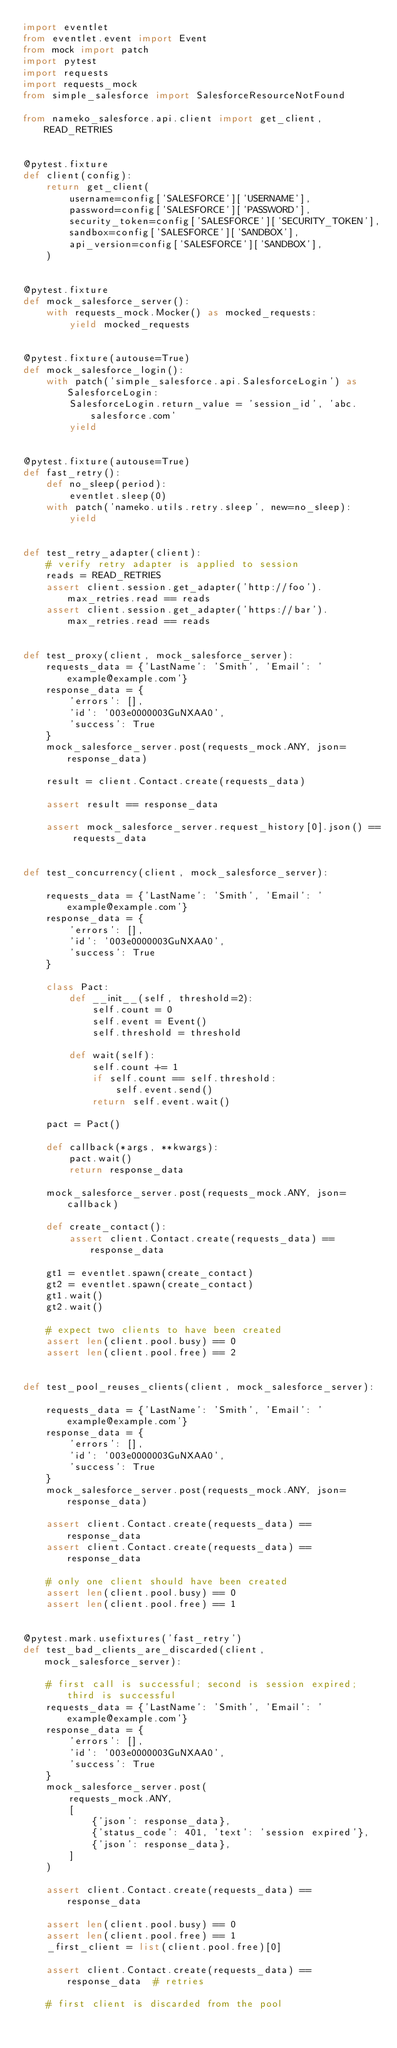<code> <loc_0><loc_0><loc_500><loc_500><_Python_>import eventlet
from eventlet.event import Event
from mock import patch
import pytest
import requests
import requests_mock
from simple_salesforce import SalesforceResourceNotFound

from nameko_salesforce.api.client import get_client, READ_RETRIES


@pytest.fixture
def client(config):
    return get_client(
        username=config['SALESFORCE']['USERNAME'],
        password=config['SALESFORCE']['PASSWORD'],
        security_token=config['SALESFORCE']['SECURITY_TOKEN'],
        sandbox=config['SALESFORCE']['SANDBOX'],
        api_version=config['SALESFORCE']['SANDBOX'],
    )


@pytest.fixture
def mock_salesforce_server():
    with requests_mock.Mocker() as mocked_requests:
        yield mocked_requests


@pytest.fixture(autouse=True)
def mock_salesforce_login():
    with patch('simple_salesforce.api.SalesforceLogin') as SalesforceLogin:
        SalesforceLogin.return_value = 'session_id', 'abc.salesforce.com'
        yield


@pytest.fixture(autouse=True)
def fast_retry():
    def no_sleep(period):
        eventlet.sleep(0)
    with patch('nameko.utils.retry.sleep', new=no_sleep):
        yield


def test_retry_adapter(client):
    # verify retry adapter is applied to session
    reads = READ_RETRIES
    assert client.session.get_adapter('http://foo').max_retries.read == reads
    assert client.session.get_adapter('https://bar').max_retries.read == reads


def test_proxy(client, mock_salesforce_server):
    requests_data = {'LastName': 'Smith', 'Email': 'example@example.com'}
    response_data = {
        'errors': [],
        'id': '003e0000003GuNXAA0',
        'success': True
    }
    mock_salesforce_server.post(requests_mock.ANY, json=response_data)

    result = client.Contact.create(requests_data)

    assert result == response_data

    assert mock_salesforce_server.request_history[0].json() == requests_data


def test_concurrency(client, mock_salesforce_server):

    requests_data = {'LastName': 'Smith', 'Email': 'example@example.com'}
    response_data = {
        'errors': [],
        'id': '003e0000003GuNXAA0',
        'success': True
    }

    class Pact:
        def __init__(self, threshold=2):
            self.count = 0
            self.event = Event()
            self.threshold = threshold

        def wait(self):
            self.count += 1
            if self.count == self.threshold:
                self.event.send()
            return self.event.wait()

    pact = Pact()

    def callback(*args, **kwargs):
        pact.wait()
        return response_data

    mock_salesforce_server.post(requests_mock.ANY, json=callback)

    def create_contact():
        assert client.Contact.create(requests_data) == response_data

    gt1 = eventlet.spawn(create_contact)
    gt2 = eventlet.spawn(create_contact)
    gt1.wait()
    gt2.wait()

    # expect two clients to have been created
    assert len(client.pool.busy) == 0
    assert len(client.pool.free) == 2


def test_pool_reuses_clients(client, mock_salesforce_server):

    requests_data = {'LastName': 'Smith', 'Email': 'example@example.com'}
    response_data = {
        'errors': [],
        'id': '003e0000003GuNXAA0',
        'success': True
    }
    mock_salesforce_server.post(requests_mock.ANY, json=response_data)

    assert client.Contact.create(requests_data) == response_data
    assert client.Contact.create(requests_data) == response_data

    # only one client should have been created
    assert len(client.pool.busy) == 0
    assert len(client.pool.free) == 1


@pytest.mark.usefixtures('fast_retry')
def test_bad_clients_are_discarded(client, mock_salesforce_server):

    # first call is successful; second is session expired; third is successful
    requests_data = {'LastName': 'Smith', 'Email': 'example@example.com'}
    response_data = {
        'errors': [],
        'id': '003e0000003GuNXAA0',
        'success': True
    }
    mock_salesforce_server.post(
        requests_mock.ANY,
        [
            {'json': response_data},
            {'status_code': 401, 'text': 'session expired'},
            {'json': response_data},
        ]
    )

    assert client.Contact.create(requests_data) == response_data

    assert len(client.pool.busy) == 0
    assert len(client.pool.free) == 1
    _first_client = list(client.pool.free)[0]

    assert client.Contact.create(requests_data) == response_data  # retries

    # first client is discarded from the pool</code> 